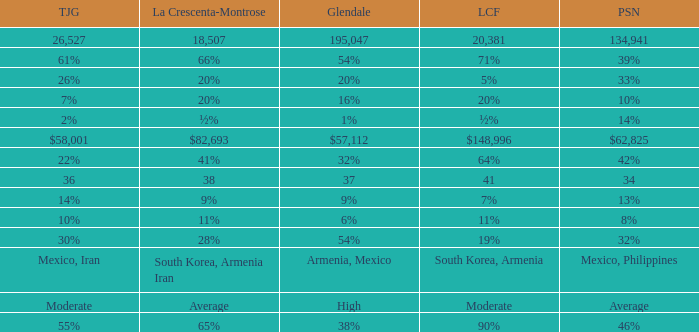What is the percentage of Tukunga when La Crescenta-Montrose is 28%? 30%. 